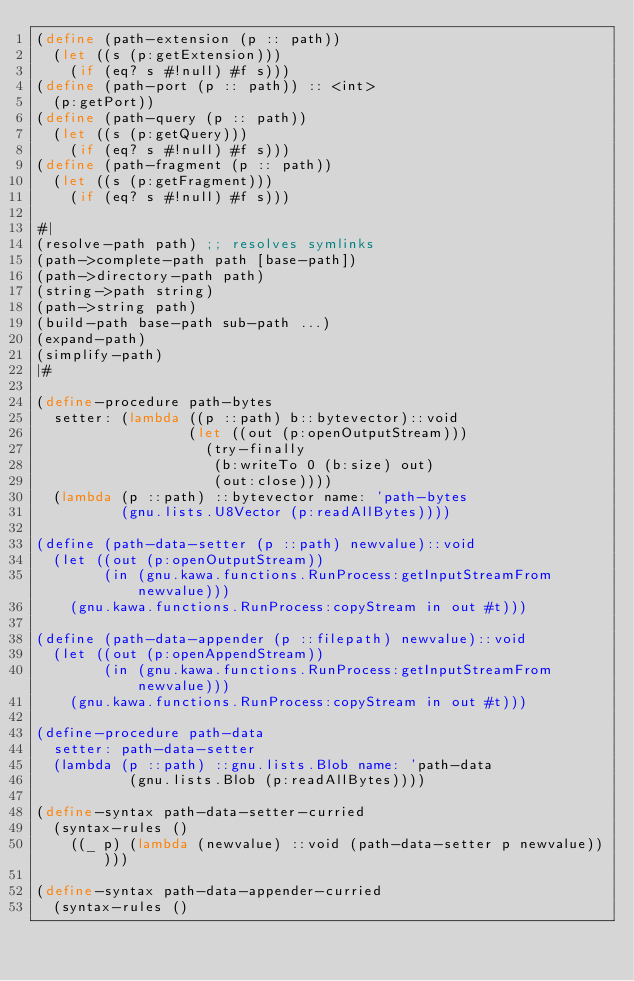<code> <loc_0><loc_0><loc_500><loc_500><_Scheme_>(define (path-extension (p :: path))
  (let ((s (p:getExtension)))
    (if (eq? s #!null) #f s)))
(define (path-port (p :: path)) :: <int>
  (p:getPort))
(define (path-query (p :: path))
  (let ((s (p:getQuery)))
    (if (eq? s #!null) #f s)))
(define (path-fragment (p :: path))
  (let ((s (p:getFragment)))
    (if (eq? s #!null) #f s)))

#|
(resolve-path path) ;; resolves symlinks
(path->complete-path path [base-path])
(path->directory-path path)
(string->path string)
(path->string path)
(build-path base-path sub-path ...)
(expand-path)
(simplify-path)
|#

(define-procedure path-bytes
  setter: (lambda ((p ::path) b::bytevector)::void
                  (let ((out (p:openOutputStream)))
                    (try-finally
                     (b:writeTo 0 (b:size) out)
                     (out:close))))
  (lambda (p ::path) ::bytevector name: 'path-bytes
          (gnu.lists.U8Vector (p:readAllBytes))))

(define (path-data-setter (p ::path) newvalue)::void
  (let ((out (p:openOutputStream))
        (in (gnu.kawa.functions.RunProcess:getInputStreamFrom newvalue)))
    (gnu.kawa.functions.RunProcess:copyStream in out #t)))

(define (path-data-appender (p ::filepath) newvalue)::void
  (let ((out (p:openAppendStream))
        (in (gnu.kawa.functions.RunProcess:getInputStreamFrom newvalue)))
    (gnu.kawa.functions.RunProcess:copyStream in out #t)))

(define-procedure path-data
  setter: path-data-setter
  (lambda (p ::path) ::gnu.lists.Blob name: 'path-data
           (gnu.lists.Blob (p:readAllBytes))))

(define-syntax path-data-setter-curried
  (syntax-rules ()
    ((_ p) (lambda (newvalue) ::void (path-data-setter p newvalue)))))

(define-syntax path-data-appender-curried
  (syntax-rules ()</code> 